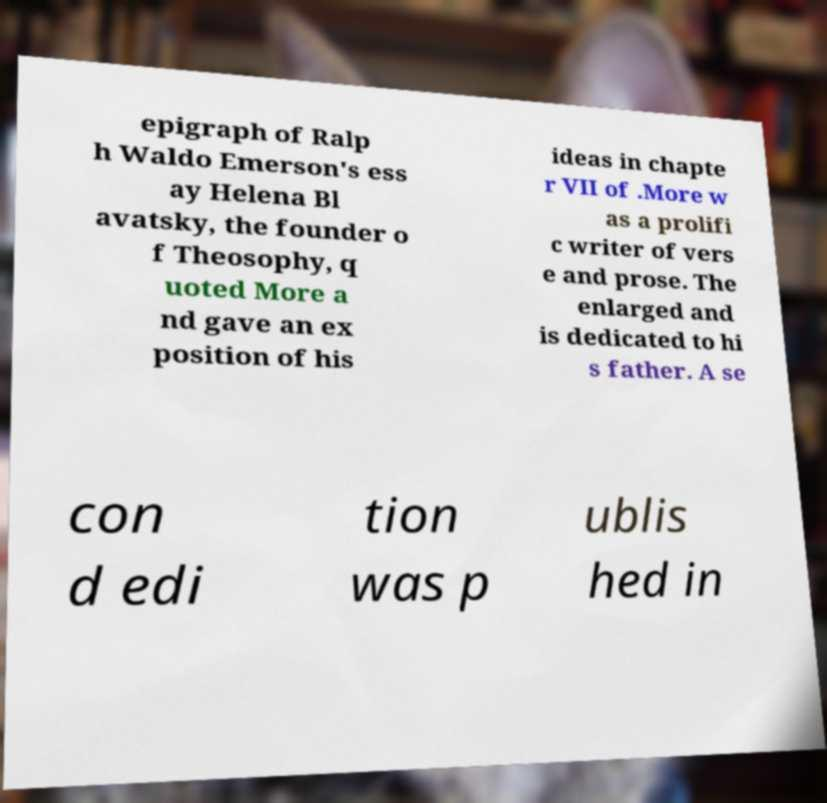Could you assist in decoding the text presented in this image and type it out clearly? epigraph of Ralp h Waldo Emerson's ess ay Helena Bl avatsky, the founder o f Theosophy, q uoted More a nd gave an ex position of his ideas in chapte r VII of .More w as a prolifi c writer of vers e and prose. The enlarged and is dedicated to hi s father. A se con d edi tion was p ublis hed in 